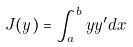Convert formula to latex. <formula><loc_0><loc_0><loc_500><loc_500>J ( y ) = \int _ { a } ^ { b } y y ^ { \prime } d x</formula> 